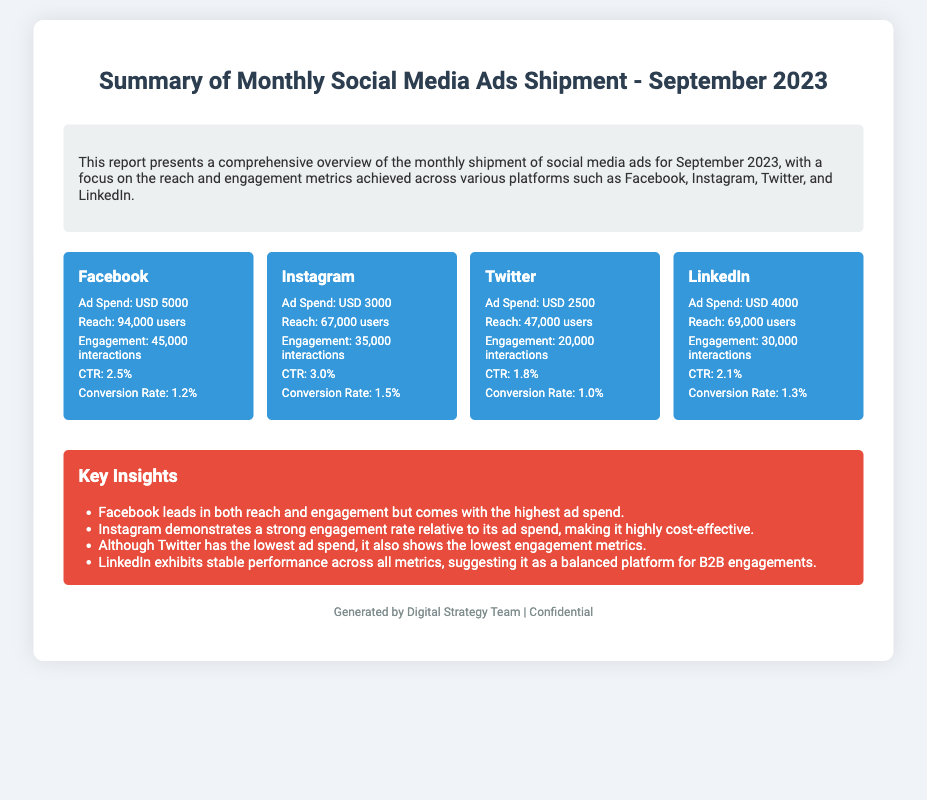What is the total ad spend for Facebook? The ad spend for Facebook is specifically listed in the document as USD 5000.
Answer: USD 5000 What is the reach achieved on Instagram? The reach for Instagram is stated in the document as 67,000 users.
Answer: 67,000 users Which platform has the highest engagement? The platform with the highest engagement is mentioned as Facebook with 45,000 interactions.
Answer: Facebook What is the CTR for Twitter? The CTR for Twitter is specifically mentioned in the document as 1.8%.
Answer: 1.8% Which platform is noted for being cost-effective? The document highlights Instagram as demonstrating a strong engagement rate relative to its ad spend, indicating cost-effectiveness.
Answer: Instagram What is the total reach across all platforms in the document? Total reach is calculated by summing the individual reaches: 94,000 + 67,000 + 47,000 + 69,000 = 277,000 users.
Answer: 277,000 users How many interactions did LinkedIn generate? The document lists that LinkedIn generated 30,000 interactions.
Answer: 30,000 interactions What insight is provided about Twitter's performance? The document states that Twitter has the lowest engagement metrics despite having the lowest ad spend.
Answer: Lowest engagement metrics Which platform has a conversion rate of 1.5%? The conversion rate of 1.5% is associated with Instagram according to the document.
Answer: Instagram 